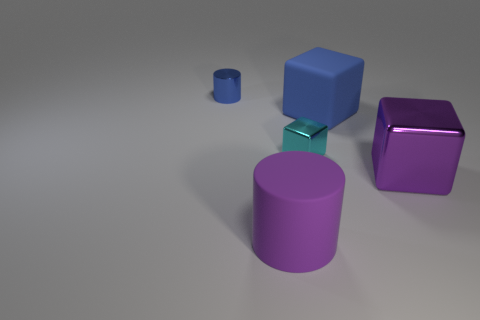Subtract all shiny cubes. How many cubes are left? 1 Subtract 1 cubes. How many cubes are left? 2 Add 1 blue things. How many objects exist? 6 Subtract all blocks. How many objects are left? 2 Subtract all small yellow rubber things. Subtract all large purple metallic cubes. How many objects are left? 4 Add 1 large objects. How many large objects are left? 4 Add 4 blue matte cubes. How many blue matte cubes exist? 5 Subtract 0 brown cylinders. How many objects are left? 5 